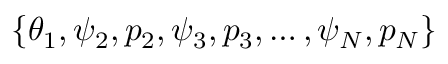Convert formula to latex. <formula><loc_0><loc_0><loc_500><loc_500>\{ \theta _ { 1 } , \psi _ { 2 } , p _ { 2 } , \psi _ { 3 } , p _ { 3 } , \hdots , \psi _ { N } , p _ { N } \}</formula> 